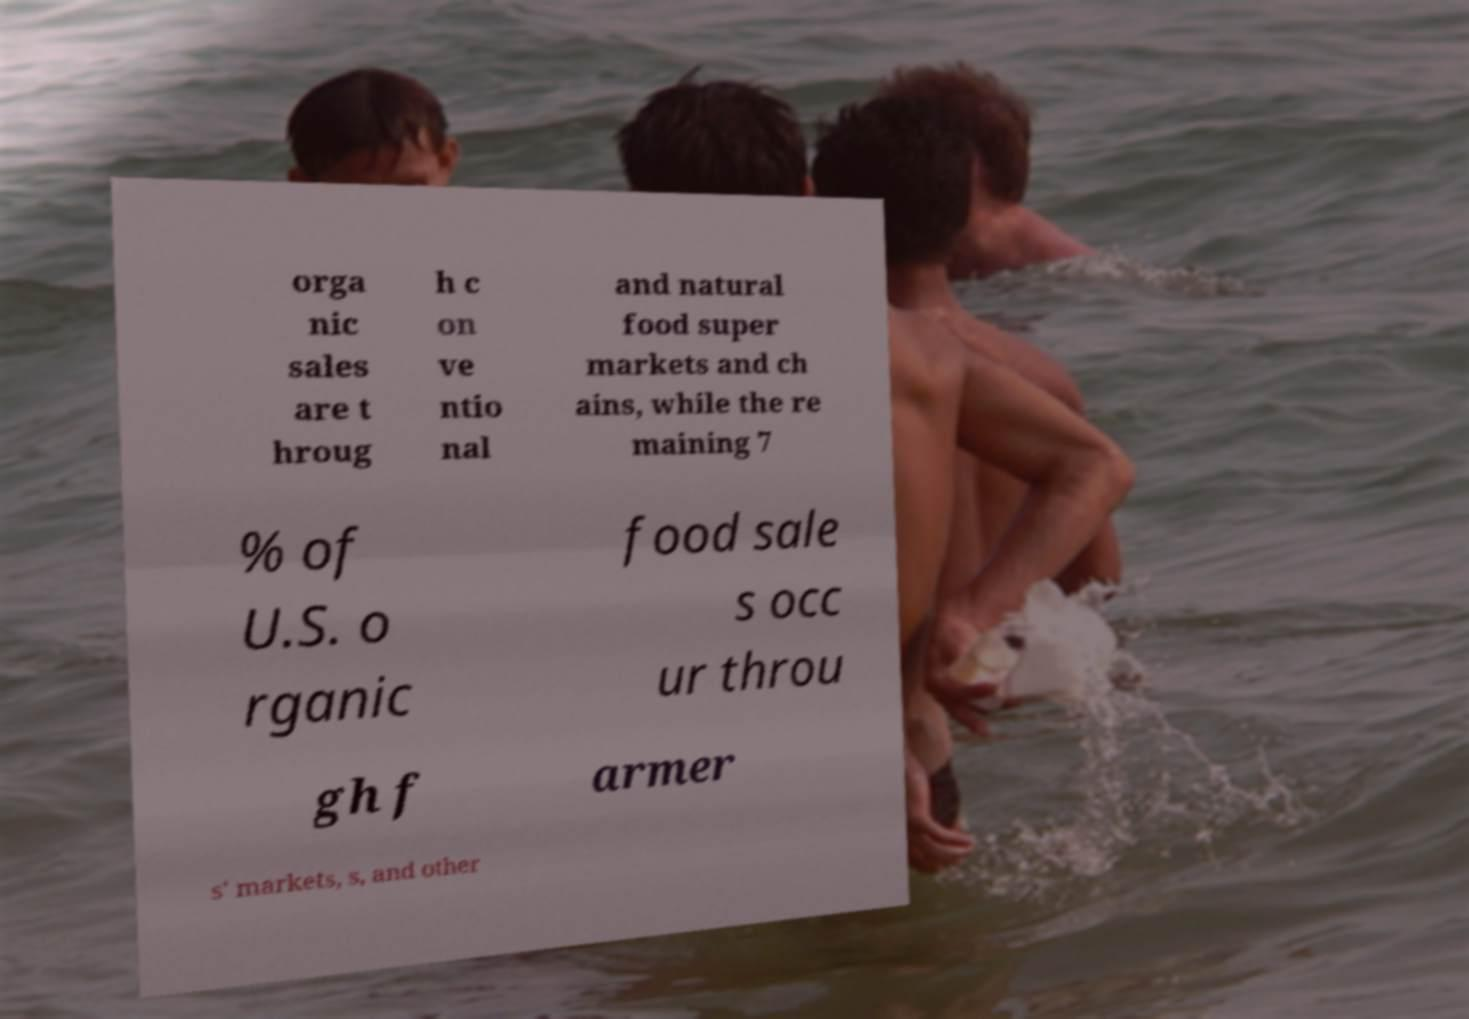Can you read and provide the text displayed in the image?This photo seems to have some interesting text. Can you extract and type it out for me? orga nic sales are t hroug h c on ve ntio nal and natural food super markets and ch ains, while the re maining 7 % of U.S. o rganic food sale s occ ur throu gh f armer s' markets, s, and other 